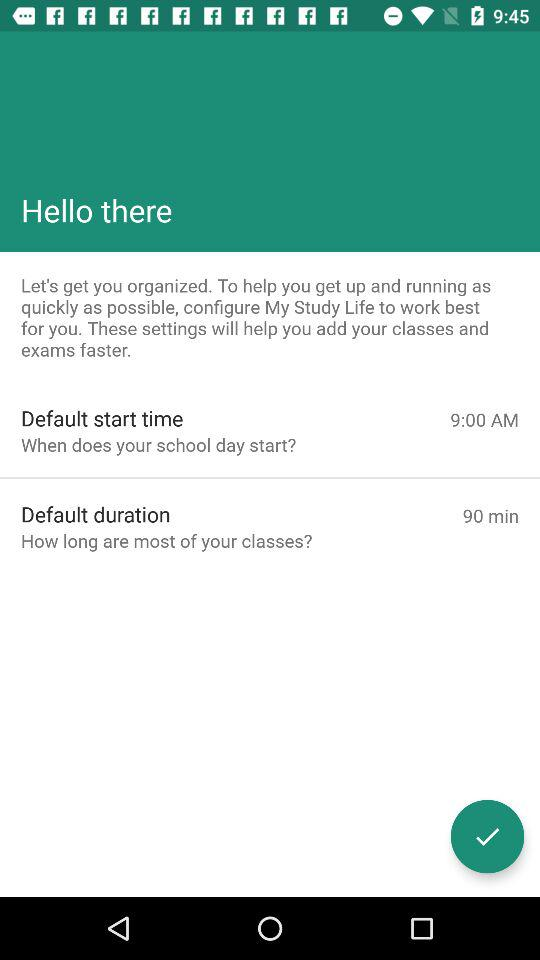What time does your school day start? Your school day starts at 9:00 a.m. 